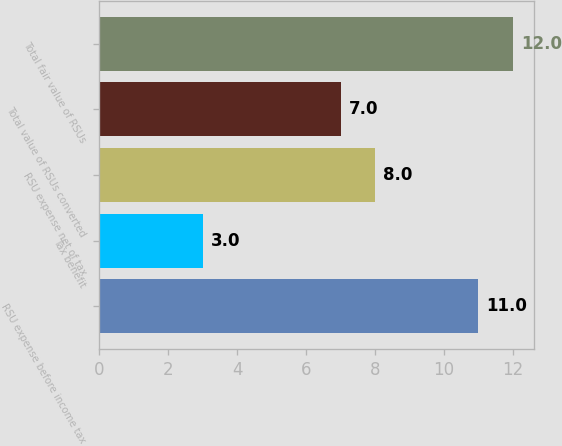Convert chart to OTSL. <chart><loc_0><loc_0><loc_500><loc_500><bar_chart><fcel>RSU expense before income tax<fcel>Tax benefit<fcel>RSU expense net of tax<fcel>Total value of RSUs converted<fcel>Total fair value of RSUs<nl><fcel>11<fcel>3<fcel>8<fcel>7<fcel>12<nl></chart> 